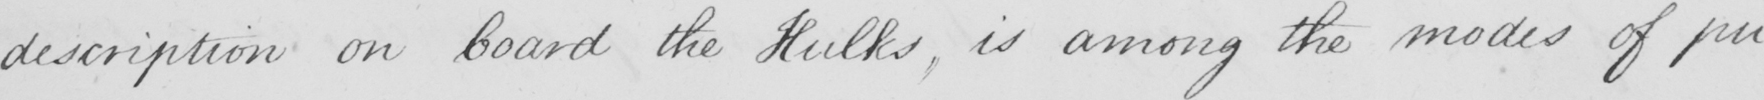What does this handwritten line say? description on board the Hulks , is among the modes of pu- 